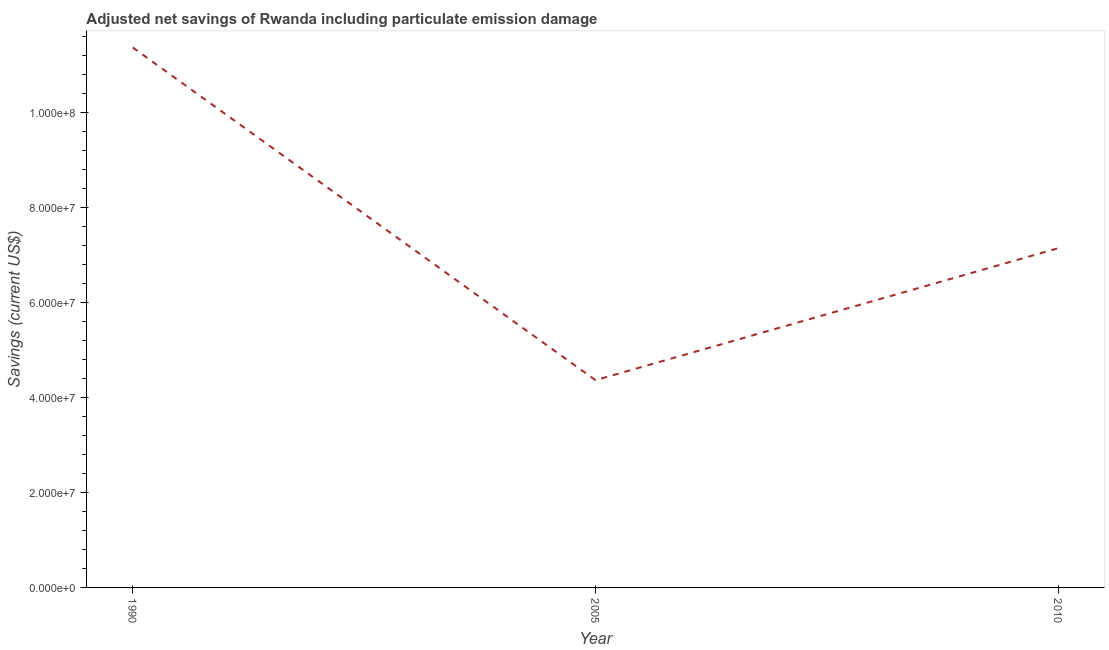What is the adjusted net savings in 2010?
Give a very brief answer. 7.14e+07. Across all years, what is the maximum adjusted net savings?
Your answer should be very brief. 1.14e+08. Across all years, what is the minimum adjusted net savings?
Give a very brief answer. 4.36e+07. In which year was the adjusted net savings minimum?
Make the answer very short. 2005. What is the sum of the adjusted net savings?
Offer a terse response. 2.29e+08. What is the difference between the adjusted net savings in 2005 and 2010?
Provide a short and direct response. -2.78e+07. What is the average adjusted net savings per year?
Offer a terse response. 7.63e+07. What is the median adjusted net savings?
Provide a short and direct response. 7.14e+07. In how many years, is the adjusted net savings greater than 12000000 US$?
Ensure brevity in your answer.  3. What is the ratio of the adjusted net savings in 2005 to that in 2010?
Ensure brevity in your answer.  0.61. What is the difference between the highest and the second highest adjusted net savings?
Give a very brief answer. 4.23e+07. What is the difference between the highest and the lowest adjusted net savings?
Your response must be concise. 7.01e+07. In how many years, is the adjusted net savings greater than the average adjusted net savings taken over all years?
Offer a very short reply. 1. Does the adjusted net savings monotonically increase over the years?
Your response must be concise. No. How many lines are there?
Provide a short and direct response. 1. What is the difference between two consecutive major ticks on the Y-axis?
Ensure brevity in your answer.  2.00e+07. What is the title of the graph?
Make the answer very short. Adjusted net savings of Rwanda including particulate emission damage. What is the label or title of the Y-axis?
Offer a very short reply. Savings (current US$). What is the Savings (current US$) of 1990?
Make the answer very short. 1.14e+08. What is the Savings (current US$) of 2005?
Your answer should be compact. 4.36e+07. What is the Savings (current US$) in 2010?
Ensure brevity in your answer.  7.14e+07. What is the difference between the Savings (current US$) in 1990 and 2005?
Your answer should be compact. 7.01e+07. What is the difference between the Savings (current US$) in 1990 and 2010?
Give a very brief answer. 4.23e+07. What is the difference between the Savings (current US$) in 2005 and 2010?
Offer a terse response. -2.78e+07. What is the ratio of the Savings (current US$) in 1990 to that in 2005?
Keep it short and to the point. 2.61. What is the ratio of the Savings (current US$) in 1990 to that in 2010?
Give a very brief answer. 1.59. What is the ratio of the Savings (current US$) in 2005 to that in 2010?
Offer a very short reply. 0.61. 